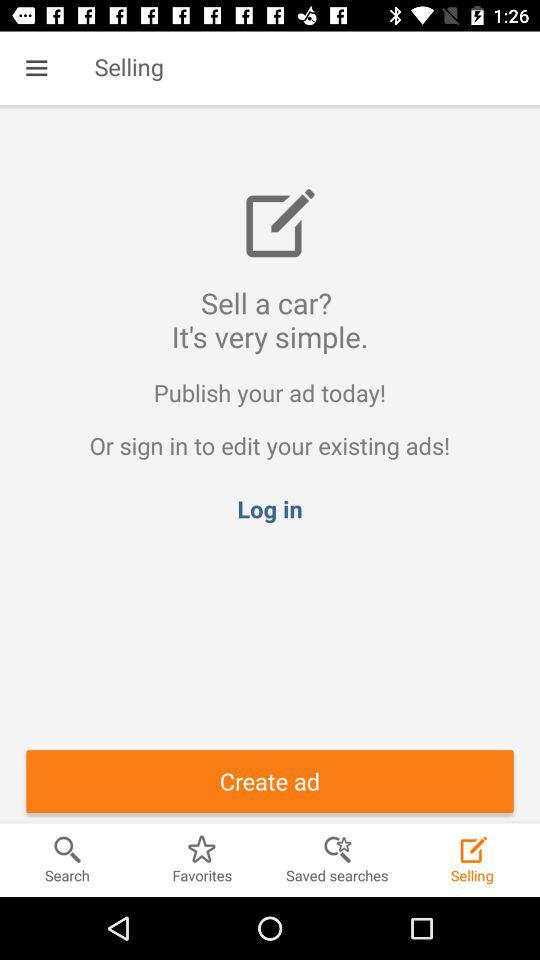Which tab of the application are we currently on? You are currently on the "Selling" tab. 